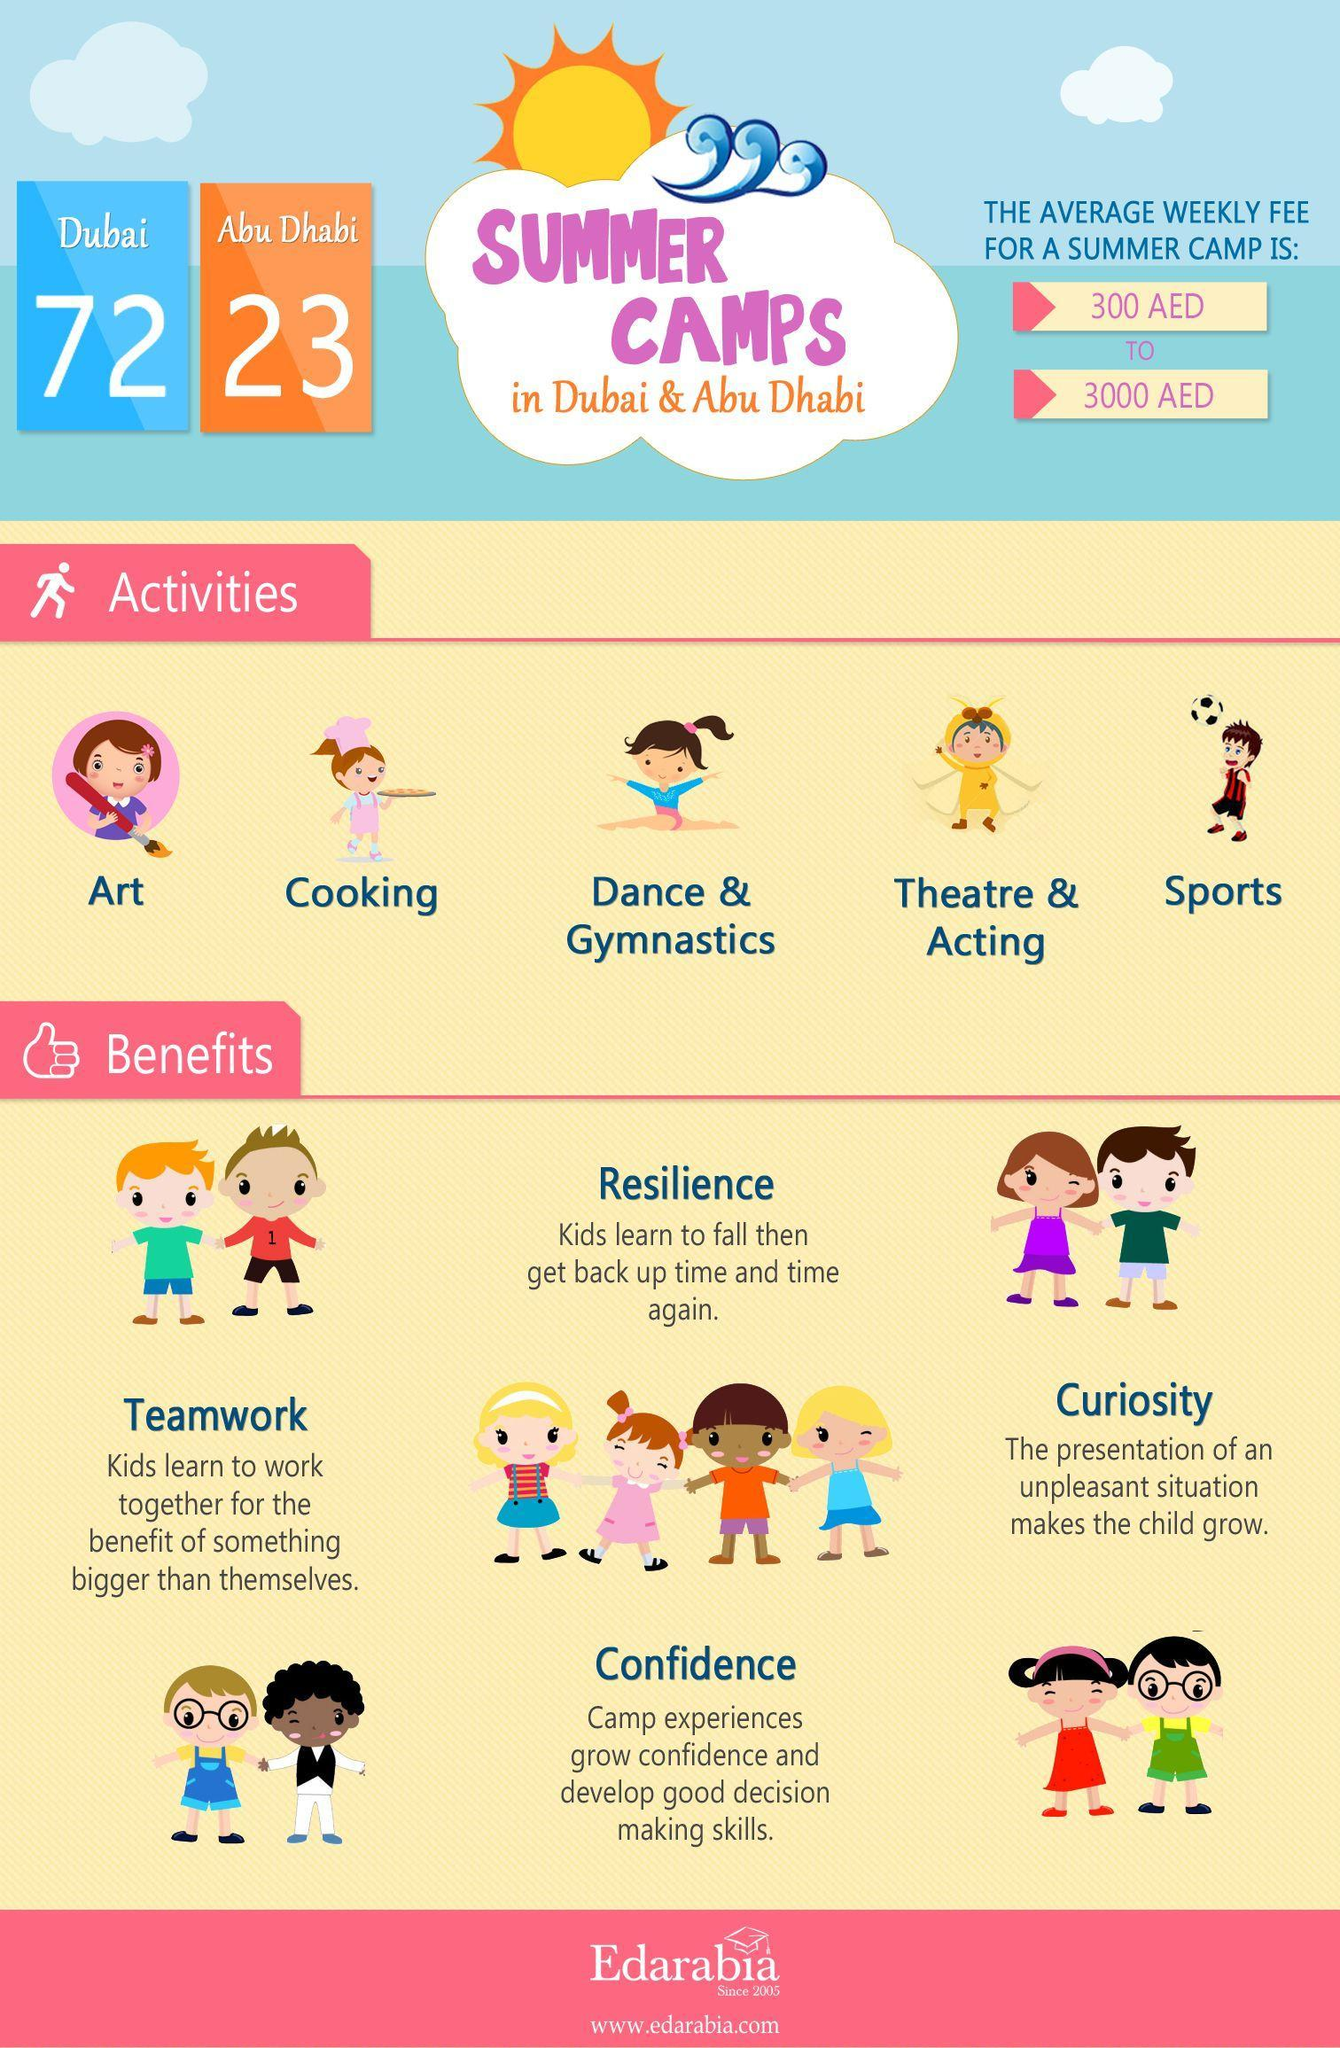What is the number of summer camps in Abu Dhabi?
Answer the question with a short phrase. 23 What is the number of summer camps in Dubai? 72 What is the number of activities in summer camps? 5 